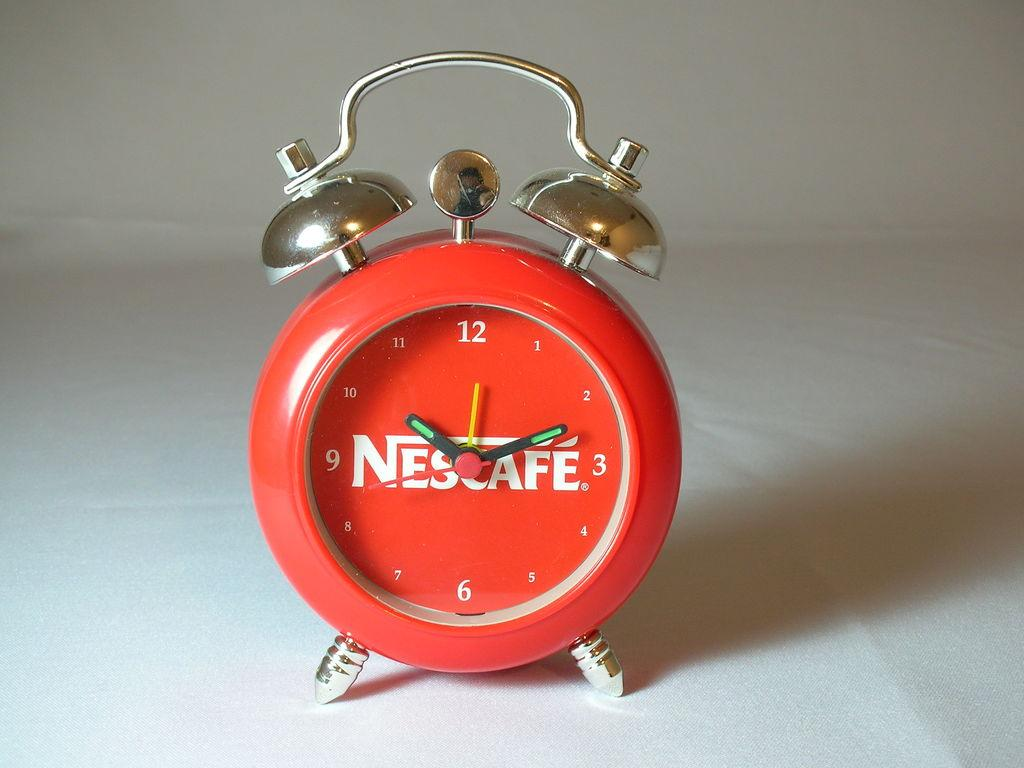<image>
Present a compact description of the photo's key features. A red Nescafe alarm clock showing a tie of 10:10 